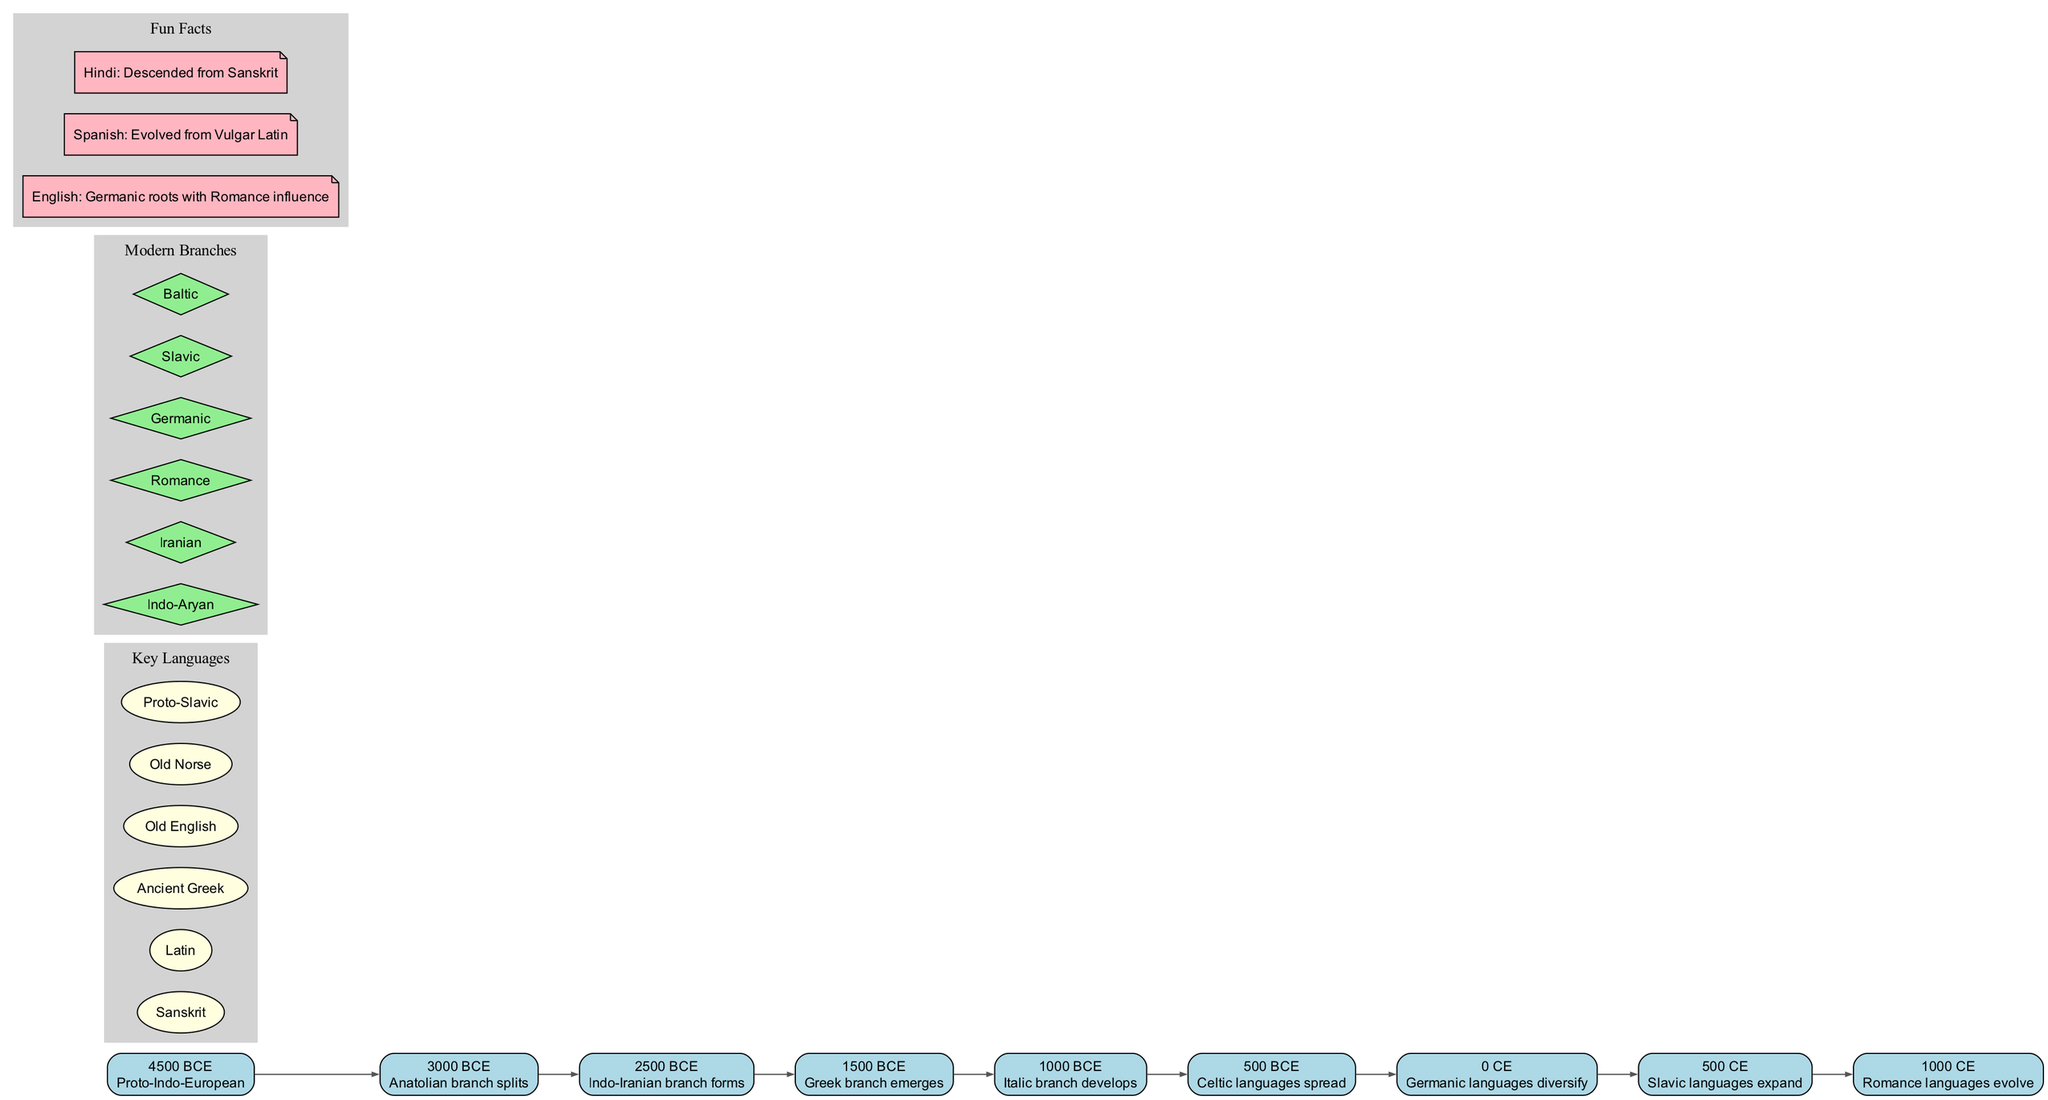What year did Proto-Indo-European emerge? The timeline indicates that Proto-Indo-European emerged in 4500 BCE, as the first event listed.
Answer: 4500 BCE Which branch split in 3000 BCE? The timeline shows that the Anatolian branch splits at 3000 BCE, marking the event on the diagram.
Answer: Anatolian branch What is the last language branch mentioned in the diagram? The diagram presents the last event, which is the evolution of Romance languages at 1000 CE, indicating it as the final branch mentioned.
Answer: Romance languages How many key languages are specified in the diagram? There are six key languages listed within the "Key Languages" cluster of the diagram, which can be counted directly from that section.
Answer: 6 Which year did Slavic languages expand? The timeline specifies that Slavic languages expanded in 500 CE, making it easy to pinpoint this event.
Answer: 500 CE What is the earliest branch formation listed? The earliest branch formation mentioned in the timeline is the Indo-Iranian branch, which forms in 2500 BCE, following the split of the Anatolian branch.
Answer: Indo-Iranian branch Which two languages originated from Indo-European roots? By observing the "Fun Facts" section, both Spanish and Hindi are noted to have evolved from Vulgar Latin and descended from Sanskrit, respectively, showcasing their Indo-European roots.
Answer: Spanish, Hindi Which language family does Old Norse belong to? Old Norse is part of the Germanic family, which is indicated by the diversification of Germanic languages mentioned in the timeline.
Answer: Germanic At what point did the Greek branch emerge? The timeline indicates the emergence of the Greek branch in 1500 BCE, marking it as a significant event in the development of Indo-European languages.
Answer: 1500 BCE 